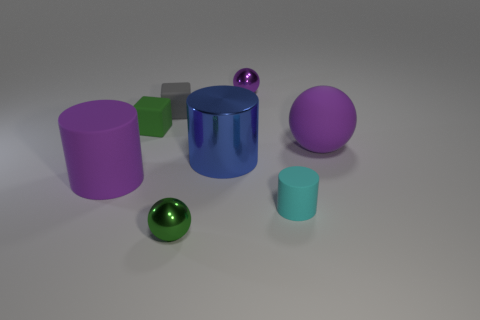Subtract all cyan cylinders. How many purple spheres are left? 2 Add 1 purple rubber cylinders. How many objects exist? 9 Subtract all large shiny cylinders. How many cylinders are left? 2 Subtract all green blocks. How many blocks are left? 1 Subtract 2 spheres. How many spheres are left? 1 Subtract all yellow cylinders. Subtract all red balls. How many cylinders are left? 3 Subtract all small gray objects. Subtract all brown rubber balls. How many objects are left? 7 Add 1 big matte cylinders. How many big matte cylinders are left? 2 Add 5 gray rubber spheres. How many gray rubber spheres exist? 5 Subtract 0 blue blocks. How many objects are left? 8 